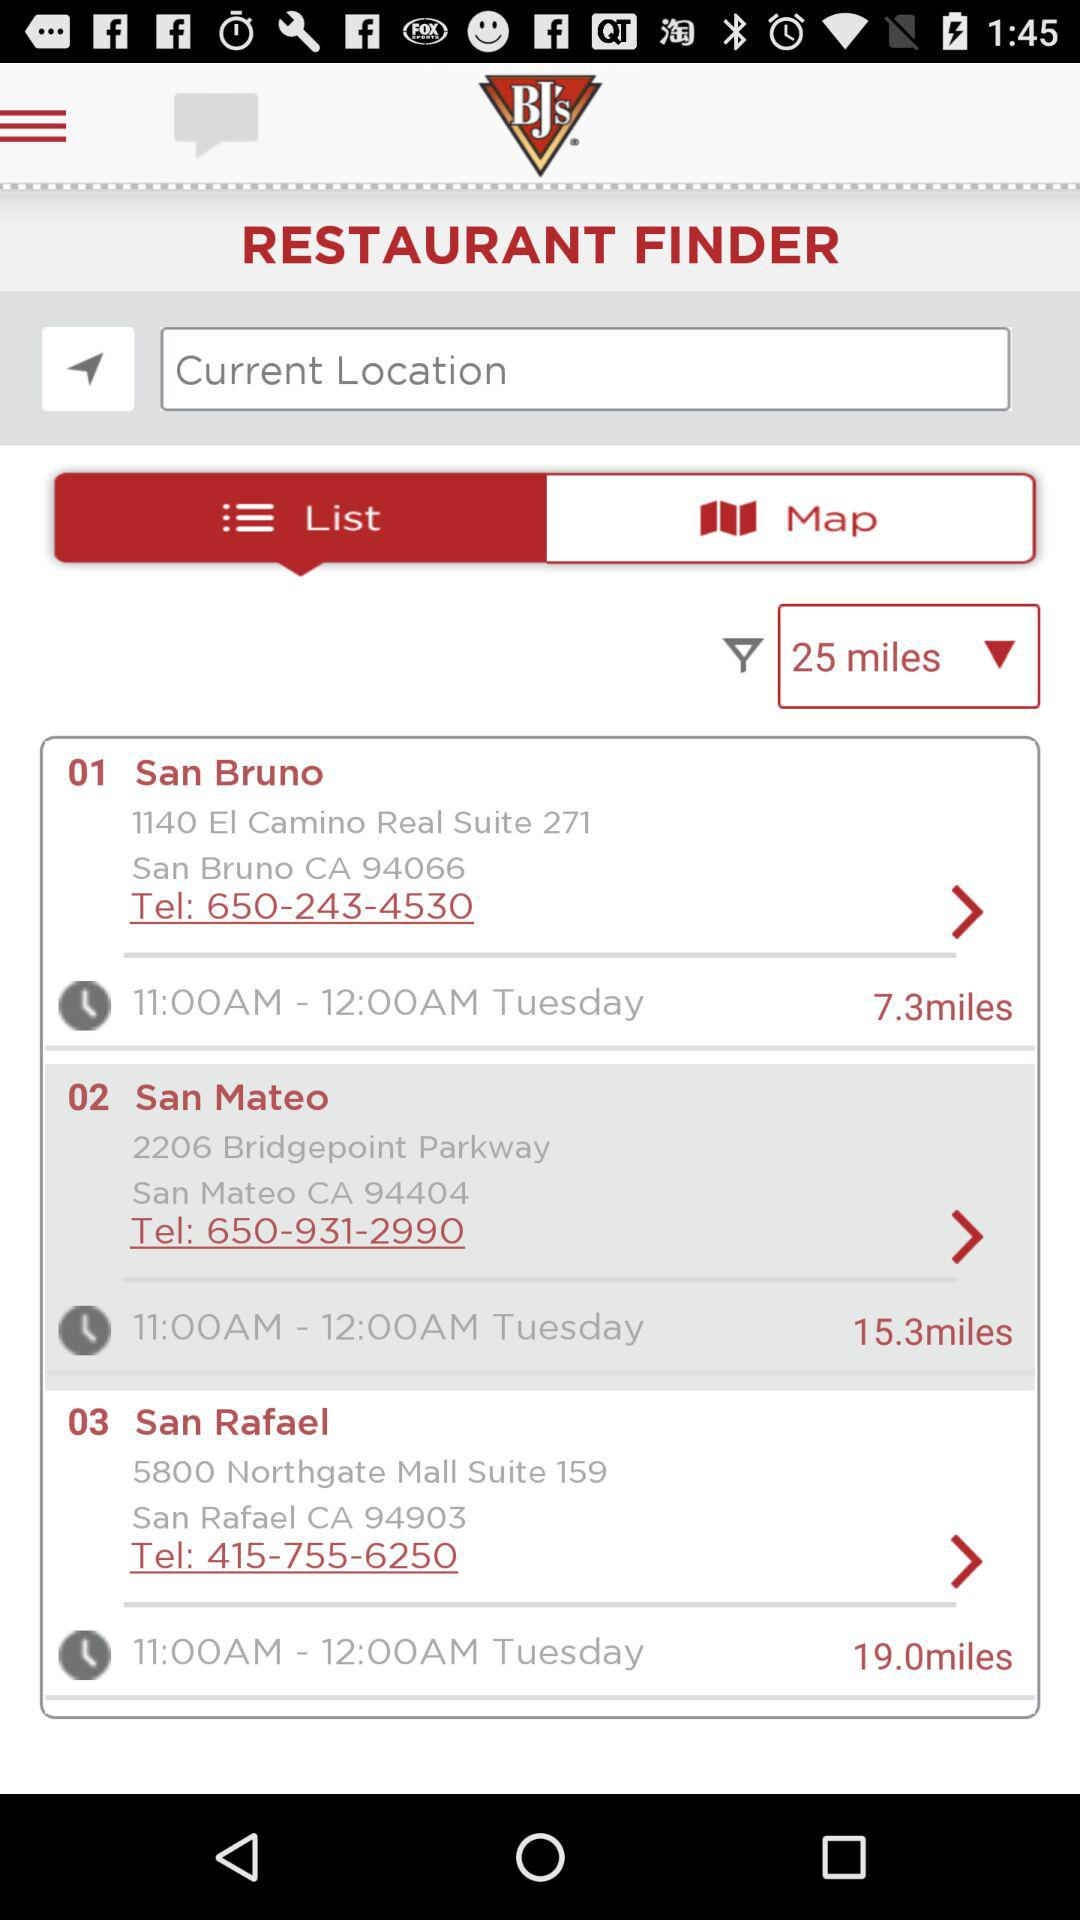What is the timing of the restaurant in San Rafael? The timing is from 11:00 a.m. to 12:00 a.m. 